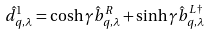<formula> <loc_0><loc_0><loc_500><loc_500>\hat { d } _ { q , \lambda } ^ { 1 } = \cosh { \gamma } \hat { b } _ { q , \lambda } ^ { R } + \sinh { \gamma } \hat { b } _ { q , \lambda } ^ { L \dagger }</formula> 